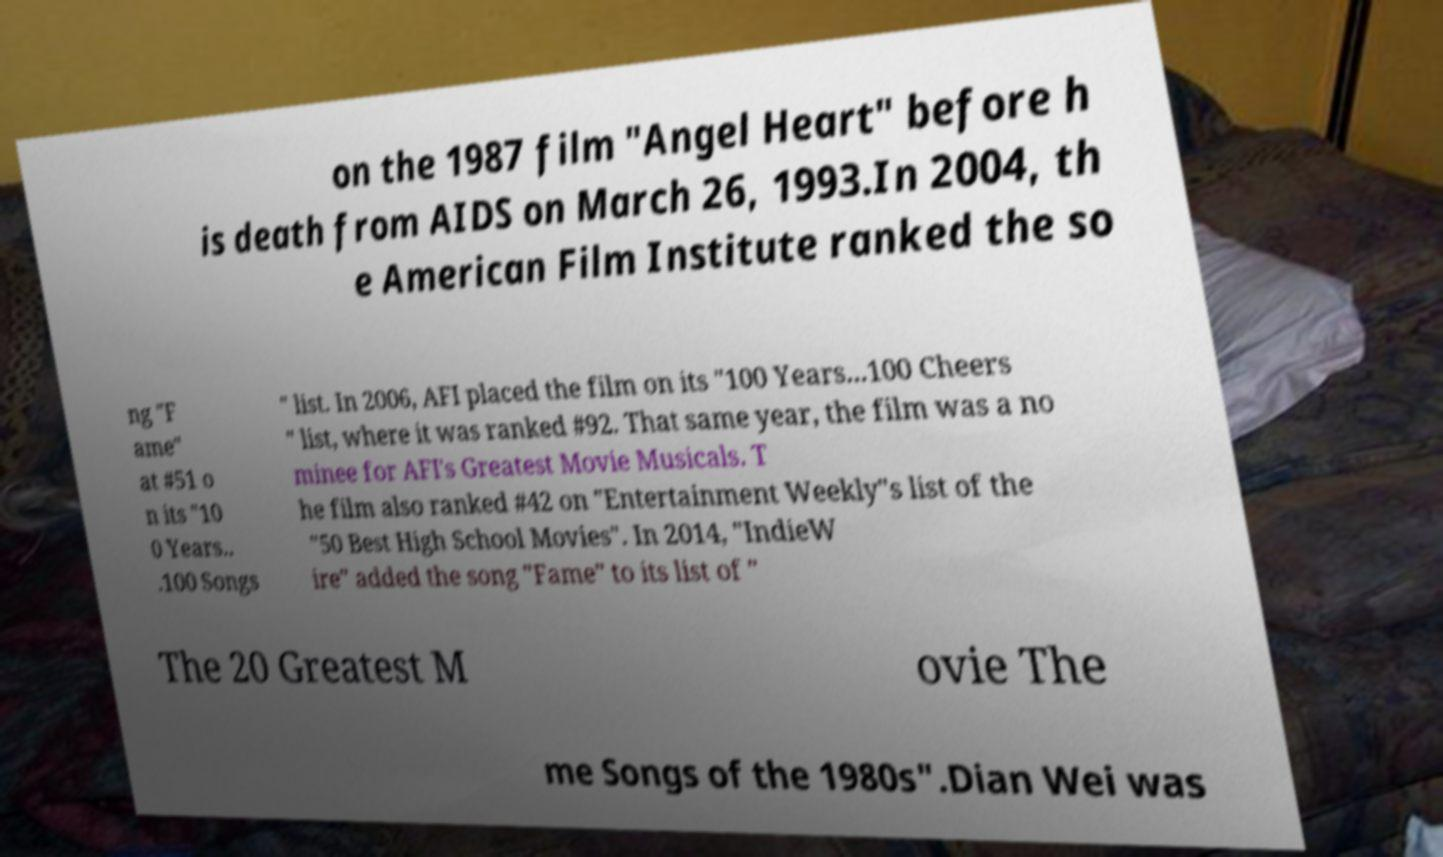Please identify and transcribe the text found in this image. on the 1987 film "Angel Heart" before h is death from AIDS on March 26, 1993.In 2004, th e American Film Institute ranked the so ng "F ame" at #51 o n its "10 0 Years.. .100 Songs " list. In 2006, AFI placed the film on its "100 Years...100 Cheers " list, where it was ranked #92. That same year, the film was a no minee for AFI's Greatest Movie Musicals. T he film also ranked #42 on "Entertainment Weekly"s list of the "50 Best High School Movies". In 2014, "IndieW ire" added the song "Fame" to its list of " The 20 Greatest M ovie The me Songs of the 1980s".Dian Wei was 